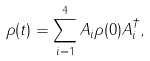Convert formula to latex. <formula><loc_0><loc_0><loc_500><loc_500>\rho ( t ) = \sum _ { i = 1 } ^ { 4 } A _ { i } \rho ( 0 ) A _ { i } ^ { \dagger } ,</formula> 